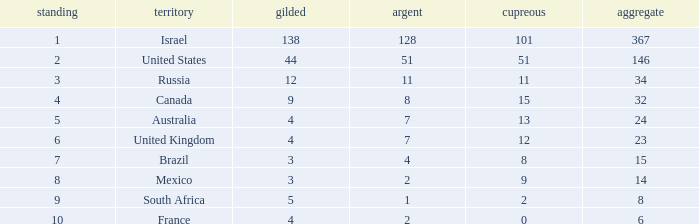What is the maximum number of silvers for a country with fewer than 12 golds and a total less than 8? 2.0. 